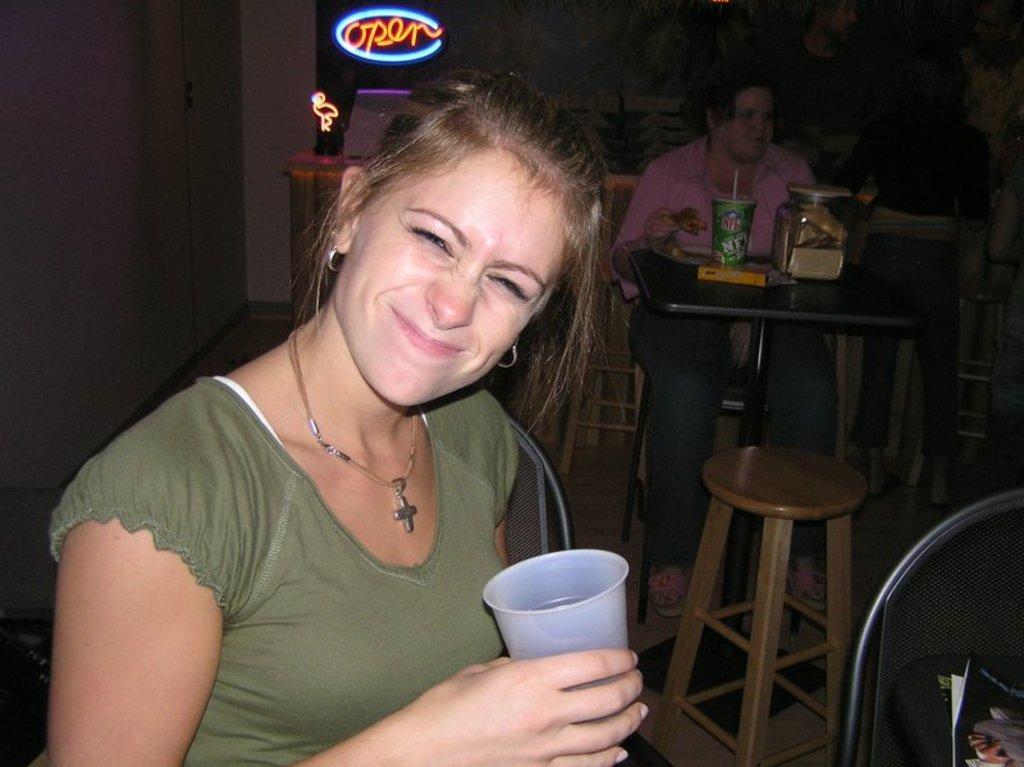Please provide a concise description of this image. In this image we can see a woman sitting on the chair and she is holding a glass in her right hand. Here we can see the smile on her face. In the background, we can see another woman sitting on the chair and she is eating. Here we can see a wooden chair on the floor. 